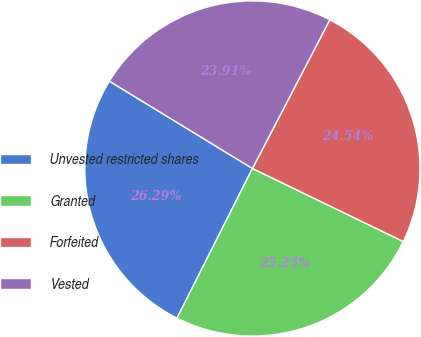Convert chart to OTSL. <chart><loc_0><loc_0><loc_500><loc_500><pie_chart><fcel>Unvested restricted shares<fcel>Granted<fcel>Forfeited<fcel>Vested<nl><fcel>26.29%<fcel>25.25%<fcel>24.54%<fcel>23.91%<nl></chart> 